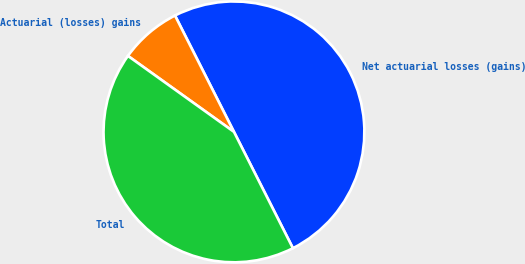Convert chart to OTSL. <chart><loc_0><loc_0><loc_500><loc_500><pie_chart><fcel>Net actuarial losses (gains)<fcel>Actuarial (losses) gains<fcel>Total<nl><fcel>50.0%<fcel>7.64%<fcel>42.36%<nl></chart> 